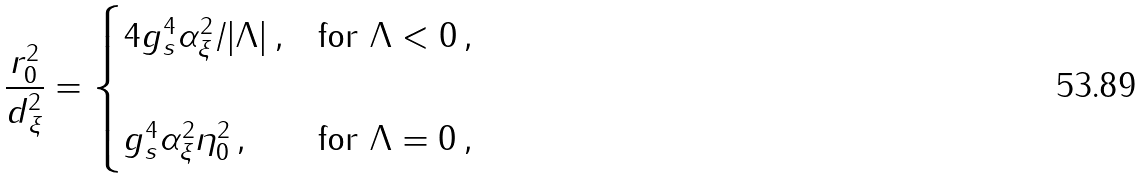<formula> <loc_0><loc_0><loc_500><loc_500>\frac { r _ { 0 } ^ { 2 } } { d _ { \xi } ^ { 2 } } = \begin{cases} 4 g ^ { 4 } _ { s } \alpha ^ { 2 } _ { \xi } / | \Lambda | \, , & \text {for $\Lambda < 0$} \, , \\ \\ g ^ { 4 } _ { s } \alpha ^ { 2 } _ { \xi } \eta ^ { 2 } _ { 0 } \, , & \text {for $\Lambda = 0$} \, , \end{cases}</formula> 